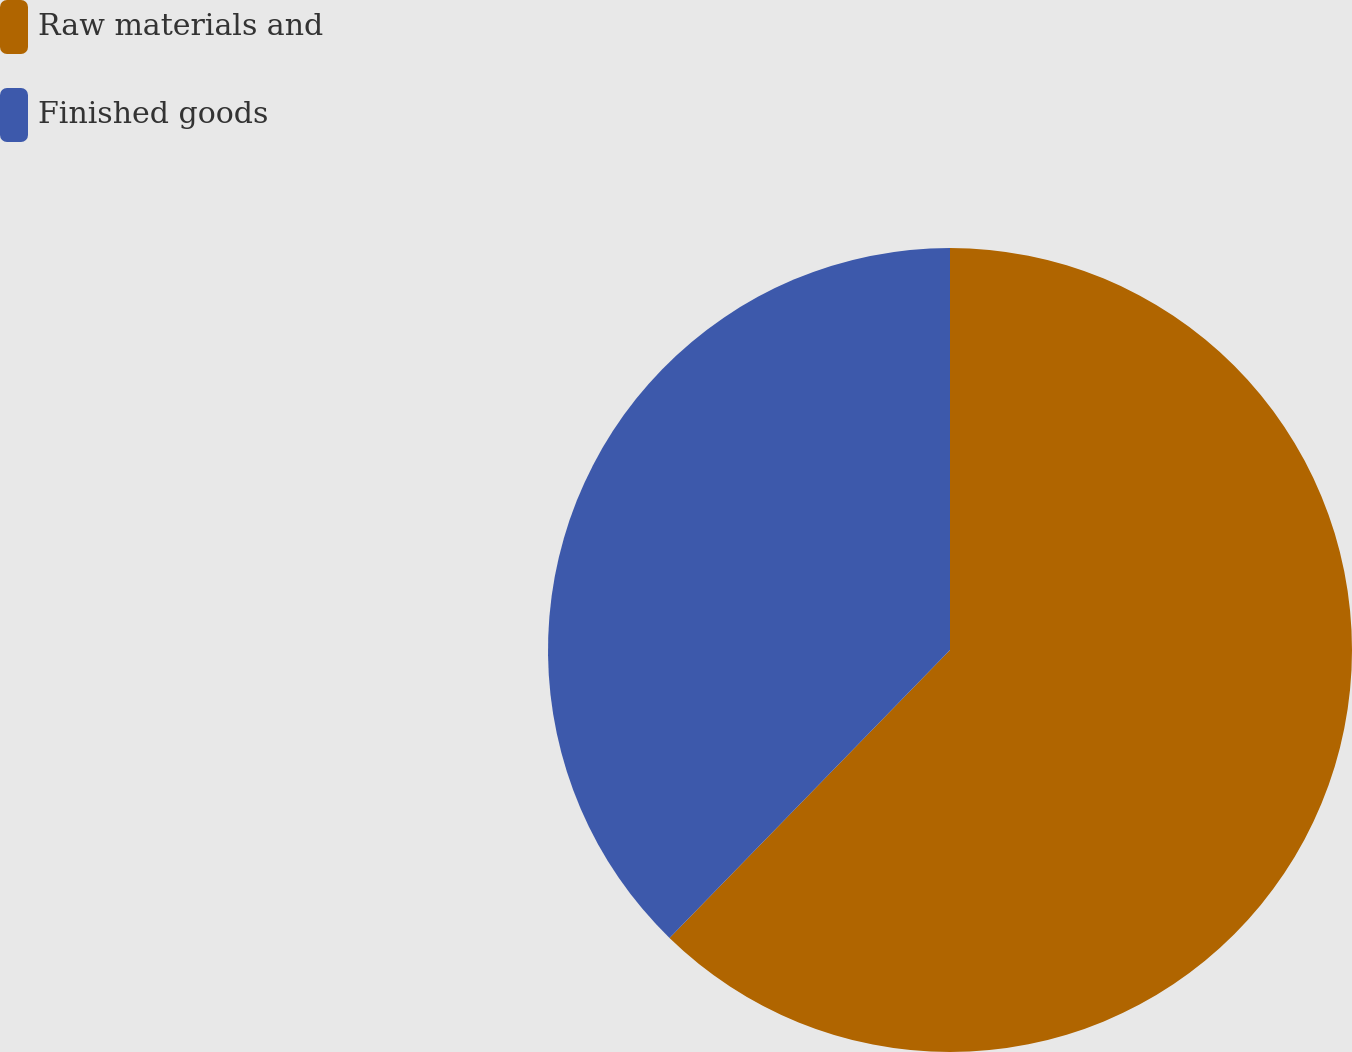Convert chart. <chart><loc_0><loc_0><loc_500><loc_500><pie_chart><fcel>Raw materials and<fcel>Finished goods<nl><fcel>62.29%<fcel>37.71%<nl></chart> 